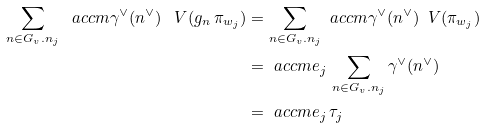<formula> <loc_0><loc_0><loc_500><loc_500>\sum _ { n \in G _ { v } . n _ { j } } \ a c c { m } { \gamma ^ { \vee } ( n ^ { \vee } ) } \, \ V ( g _ { n } \, \pi _ { w _ { j } } ) & = \sum _ { n \in G _ { v } . n _ { j } } \ a c c { m } { \gamma ^ { \vee } ( n ^ { \vee } ) } \, \ V ( \pi _ { w _ { j } } ) \\ & = \ a c c { m } { e _ { j } \, \sum _ { n \in G _ { v } . n _ { j } } \gamma ^ { \vee } ( n ^ { \vee } ) } \\ & = \ a c c { m } { e _ { j } \, \tau _ { j } }</formula> 